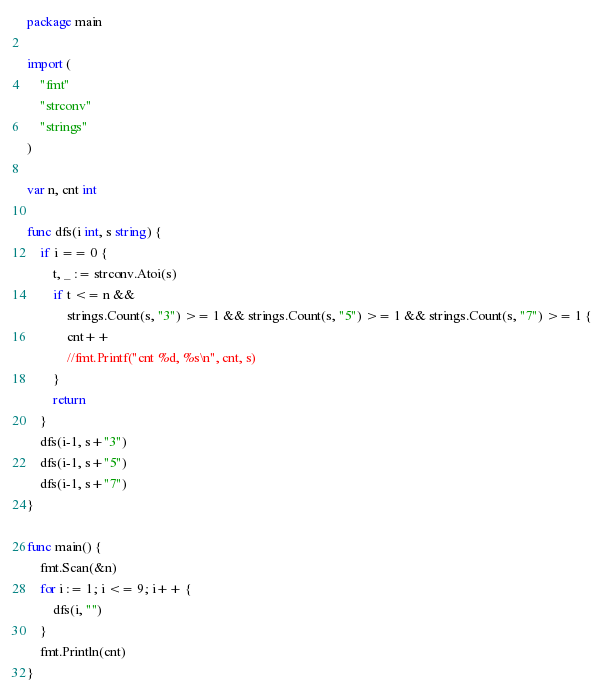Convert code to text. <code><loc_0><loc_0><loc_500><loc_500><_Go_>package main

import (
	"fmt"
	"strconv"
	"strings"
)

var n, cnt int

func dfs(i int, s string) {
	if i == 0 {
		t, _ := strconv.Atoi(s)
		if t <= n &&
			strings.Count(s, "3") >= 1 && strings.Count(s, "5") >= 1 && strings.Count(s, "7") >= 1 {
			cnt++
			//fmt.Printf("cnt %d, %s\n", cnt, s)
		}
		return
	}
	dfs(i-1, s+"3")
	dfs(i-1, s+"5")
	dfs(i-1, s+"7")
}

func main() {
	fmt.Scan(&n)
	for i := 1; i <= 9; i++ {
		dfs(i, "")
	}
	fmt.Println(cnt)
}
</code> 